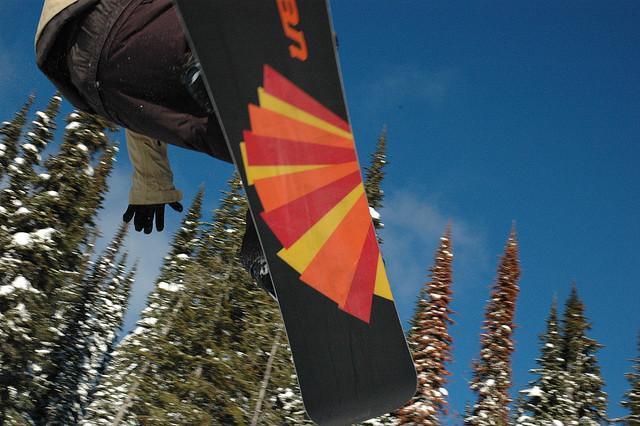How many kites are there?
Give a very brief answer. 0. How many orange slices can you see?
Give a very brief answer. 0. 